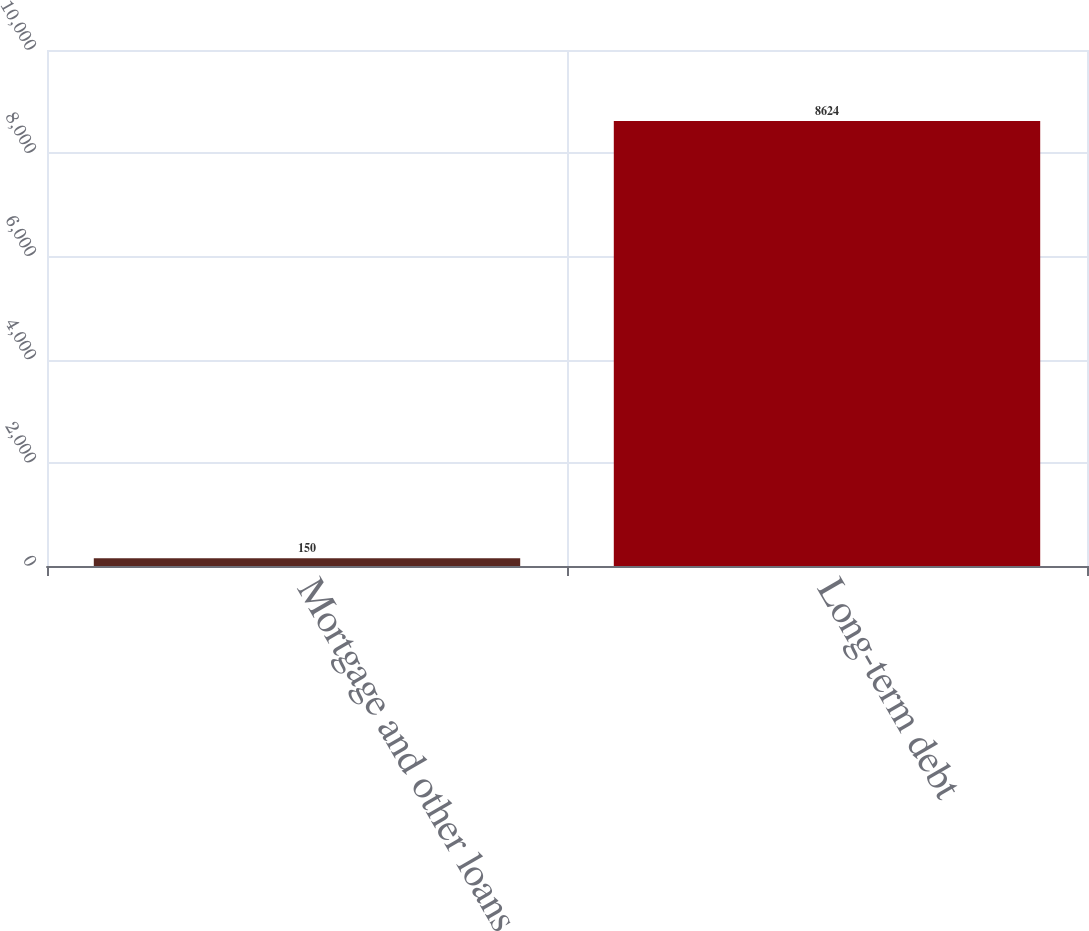Convert chart to OTSL. <chart><loc_0><loc_0><loc_500><loc_500><bar_chart><fcel>Mortgage and other loans<fcel>Long-term debt<nl><fcel>150<fcel>8624<nl></chart> 